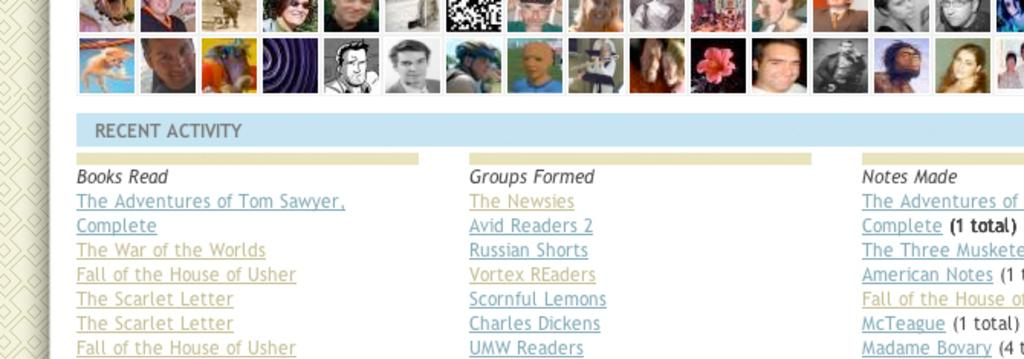What type of image is shown in the screenshot? The image is a screenshot from a web page. What can be seen at the top of the web page? There are multiple persons' images on the top of the web page. What is located at the bottom of the web page? There is text written at the bottom of the web page. What type of bird can be seen in the brass bait at the top of the web page? There is no bird or brass bait present in the image; it is a screenshot of a web page with multiple persons' images at the top and text at the bottom. 